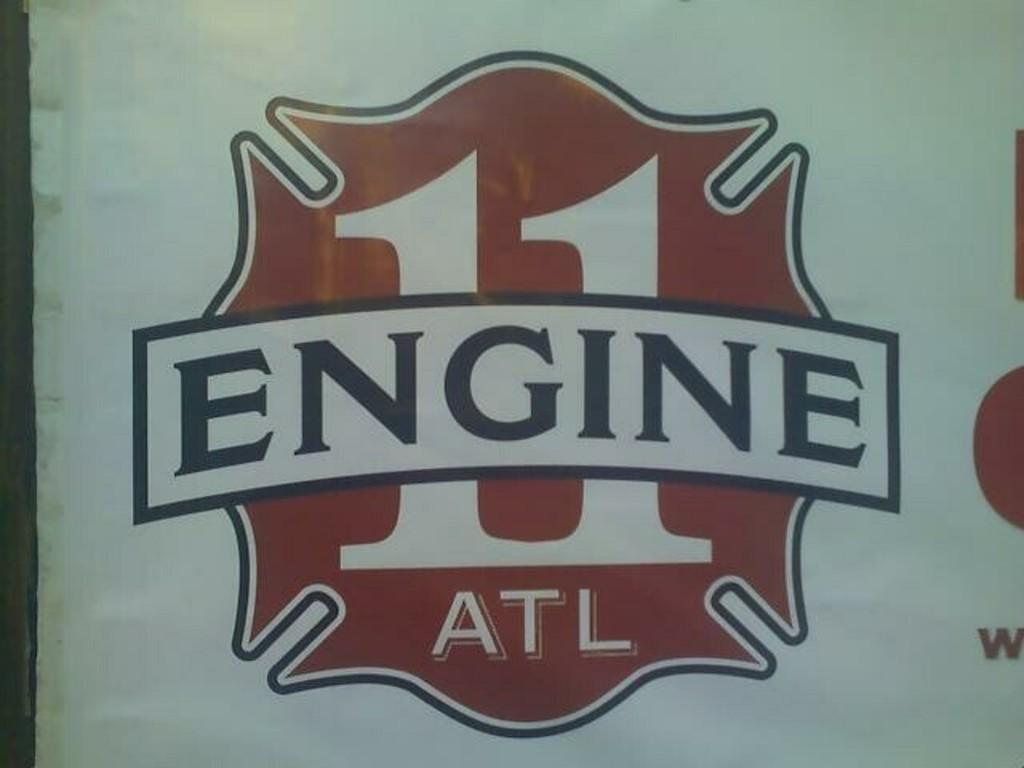<image>
Give a short and clear explanation of the subsequent image. A red, white, and black design for Engine 11 ATL. 